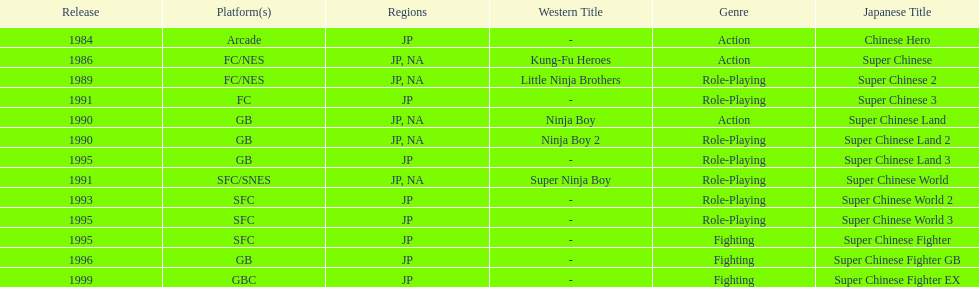When was the last super chinese game released? 1999. 